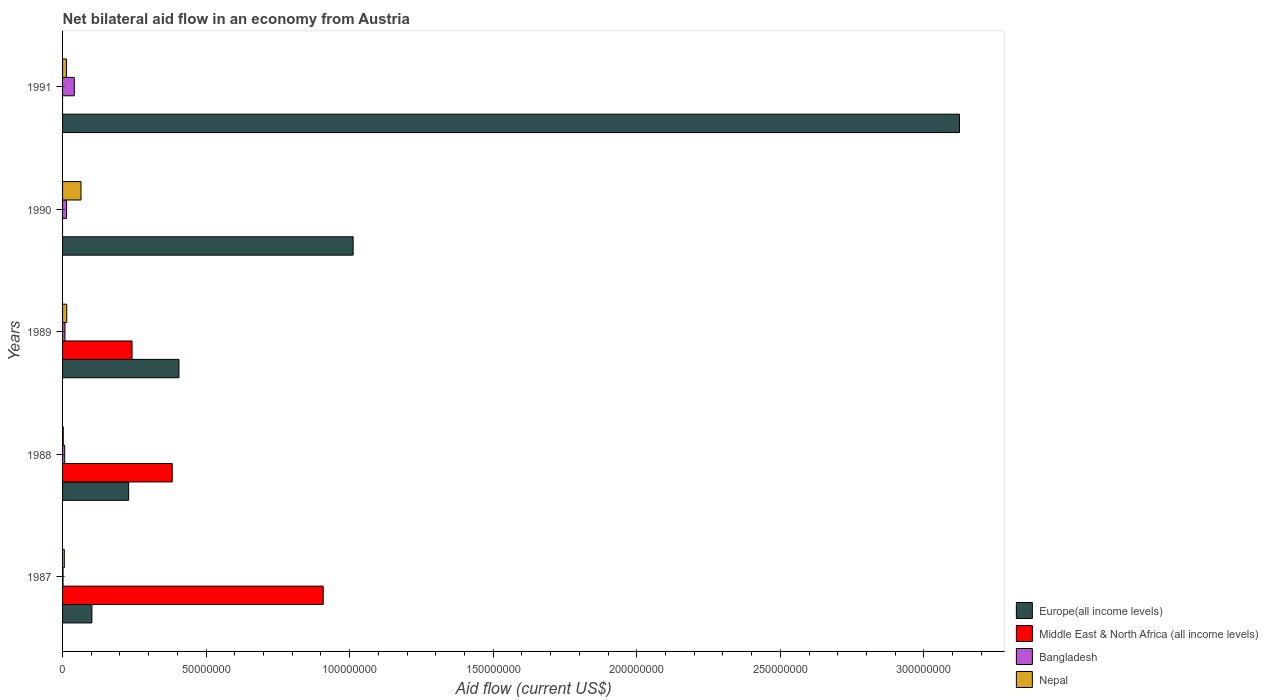Are the number of bars per tick equal to the number of legend labels?
Make the answer very short. No. What is the label of the 3rd group of bars from the top?
Your answer should be very brief. 1989. What is the net bilateral aid flow in Middle East & North Africa (all income levels) in 1989?
Ensure brevity in your answer.  2.42e+07. Across all years, what is the maximum net bilateral aid flow in Bangladesh?
Provide a succinct answer. 4.08e+06. In which year was the net bilateral aid flow in Bangladesh maximum?
Your response must be concise. 1991. What is the total net bilateral aid flow in Bangladesh in the graph?
Your answer should be very brief. 7.21e+06. What is the difference between the net bilateral aid flow in Europe(all income levels) in 1990 and the net bilateral aid flow in Nepal in 1988?
Offer a very short reply. 1.01e+08. What is the average net bilateral aid flow in Middle East & North Africa (all income levels) per year?
Offer a terse response. 3.06e+07. In the year 1987, what is the difference between the net bilateral aid flow in Middle East & North Africa (all income levels) and net bilateral aid flow in Nepal?
Provide a short and direct response. 9.02e+07. In how many years, is the net bilateral aid flow in Bangladesh greater than 20000000 US$?
Provide a short and direct response. 0. What is the ratio of the net bilateral aid flow in Nepal in 1989 to that in 1990?
Give a very brief answer. 0.23. Is the net bilateral aid flow in Nepal in 1987 less than that in 1990?
Your answer should be compact. Yes. Is the difference between the net bilateral aid flow in Middle East & North Africa (all income levels) in 1988 and 1989 greater than the difference between the net bilateral aid flow in Nepal in 1988 and 1989?
Your response must be concise. Yes. What is the difference between the highest and the second highest net bilateral aid flow in Middle East & North Africa (all income levels)?
Your answer should be very brief. 5.26e+07. What is the difference between the highest and the lowest net bilateral aid flow in Middle East & North Africa (all income levels)?
Your answer should be compact. 9.08e+07. In how many years, is the net bilateral aid flow in Europe(all income levels) greater than the average net bilateral aid flow in Europe(all income levels) taken over all years?
Ensure brevity in your answer.  2. Is the sum of the net bilateral aid flow in Europe(all income levels) in 1988 and 1990 greater than the maximum net bilateral aid flow in Middle East & North Africa (all income levels) across all years?
Your answer should be very brief. Yes. Is it the case that in every year, the sum of the net bilateral aid flow in Europe(all income levels) and net bilateral aid flow in Bangladesh is greater than the net bilateral aid flow in Nepal?
Your answer should be very brief. Yes. How many years are there in the graph?
Make the answer very short. 5. Where does the legend appear in the graph?
Ensure brevity in your answer.  Bottom right. How are the legend labels stacked?
Provide a succinct answer. Vertical. What is the title of the graph?
Provide a succinct answer. Net bilateral aid flow in an economy from Austria. What is the label or title of the Y-axis?
Provide a succinct answer. Years. What is the Aid flow (current US$) in Europe(all income levels) in 1987?
Your answer should be compact. 1.02e+07. What is the Aid flow (current US$) of Middle East & North Africa (all income levels) in 1987?
Offer a terse response. 9.08e+07. What is the Aid flow (current US$) in Bangladesh in 1987?
Your answer should be compact. 1.60e+05. What is the Aid flow (current US$) in Europe(all income levels) in 1988?
Give a very brief answer. 2.30e+07. What is the Aid flow (current US$) of Middle East & North Africa (all income levels) in 1988?
Make the answer very short. 3.82e+07. What is the Aid flow (current US$) of Bangladesh in 1988?
Offer a very short reply. 7.40e+05. What is the Aid flow (current US$) of Nepal in 1988?
Your answer should be very brief. 2.50e+05. What is the Aid flow (current US$) of Europe(all income levels) in 1989?
Your answer should be compact. 4.05e+07. What is the Aid flow (current US$) of Middle East & North Africa (all income levels) in 1989?
Make the answer very short. 2.42e+07. What is the Aid flow (current US$) of Bangladesh in 1989?
Ensure brevity in your answer.  8.40e+05. What is the Aid flow (current US$) of Nepal in 1989?
Provide a succinct answer. 1.46e+06. What is the Aid flow (current US$) of Europe(all income levels) in 1990?
Your answer should be compact. 1.01e+08. What is the Aid flow (current US$) in Middle East & North Africa (all income levels) in 1990?
Provide a short and direct response. 0. What is the Aid flow (current US$) in Bangladesh in 1990?
Your answer should be compact. 1.39e+06. What is the Aid flow (current US$) of Nepal in 1990?
Provide a short and direct response. 6.42e+06. What is the Aid flow (current US$) of Europe(all income levels) in 1991?
Your response must be concise. 3.12e+08. What is the Aid flow (current US$) in Middle East & North Africa (all income levels) in 1991?
Keep it short and to the point. 0. What is the Aid flow (current US$) of Bangladesh in 1991?
Give a very brief answer. 4.08e+06. What is the Aid flow (current US$) in Nepal in 1991?
Offer a very short reply. 1.36e+06. Across all years, what is the maximum Aid flow (current US$) in Europe(all income levels)?
Your answer should be very brief. 3.12e+08. Across all years, what is the maximum Aid flow (current US$) in Middle East & North Africa (all income levels)?
Keep it short and to the point. 9.08e+07. Across all years, what is the maximum Aid flow (current US$) in Bangladesh?
Offer a very short reply. 4.08e+06. Across all years, what is the maximum Aid flow (current US$) of Nepal?
Give a very brief answer. 6.42e+06. Across all years, what is the minimum Aid flow (current US$) of Europe(all income levels)?
Keep it short and to the point. 1.02e+07. Across all years, what is the minimum Aid flow (current US$) of Middle East & North Africa (all income levels)?
Offer a very short reply. 0. What is the total Aid flow (current US$) in Europe(all income levels) in the graph?
Offer a terse response. 4.87e+08. What is the total Aid flow (current US$) in Middle East & North Africa (all income levels) in the graph?
Offer a very short reply. 1.53e+08. What is the total Aid flow (current US$) of Bangladesh in the graph?
Your answer should be very brief. 7.21e+06. What is the total Aid flow (current US$) in Nepal in the graph?
Your answer should be compact. 1.01e+07. What is the difference between the Aid flow (current US$) in Europe(all income levels) in 1987 and that in 1988?
Your response must be concise. -1.28e+07. What is the difference between the Aid flow (current US$) of Middle East & North Africa (all income levels) in 1987 and that in 1988?
Offer a very short reply. 5.26e+07. What is the difference between the Aid flow (current US$) in Bangladesh in 1987 and that in 1988?
Your response must be concise. -5.80e+05. What is the difference between the Aid flow (current US$) in Nepal in 1987 and that in 1988?
Provide a short and direct response. 3.60e+05. What is the difference between the Aid flow (current US$) in Europe(all income levels) in 1987 and that in 1989?
Ensure brevity in your answer.  -3.03e+07. What is the difference between the Aid flow (current US$) of Middle East & North Africa (all income levels) in 1987 and that in 1989?
Provide a succinct answer. 6.66e+07. What is the difference between the Aid flow (current US$) of Bangladesh in 1987 and that in 1989?
Offer a very short reply. -6.80e+05. What is the difference between the Aid flow (current US$) in Nepal in 1987 and that in 1989?
Ensure brevity in your answer.  -8.50e+05. What is the difference between the Aid flow (current US$) in Europe(all income levels) in 1987 and that in 1990?
Offer a terse response. -9.10e+07. What is the difference between the Aid flow (current US$) of Bangladesh in 1987 and that in 1990?
Offer a terse response. -1.23e+06. What is the difference between the Aid flow (current US$) of Nepal in 1987 and that in 1990?
Ensure brevity in your answer.  -5.81e+06. What is the difference between the Aid flow (current US$) of Europe(all income levels) in 1987 and that in 1991?
Your answer should be very brief. -3.02e+08. What is the difference between the Aid flow (current US$) in Bangladesh in 1987 and that in 1991?
Your answer should be very brief. -3.92e+06. What is the difference between the Aid flow (current US$) in Nepal in 1987 and that in 1991?
Your answer should be compact. -7.50e+05. What is the difference between the Aid flow (current US$) of Europe(all income levels) in 1988 and that in 1989?
Give a very brief answer. -1.75e+07. What is the difference between the Aid flow (current US$) of Middle East & North Africa (all income levels) in 1988 and that in 1989?
Ensure brevity in your answer.  1.40e+07. What is the difference between the Aid flow (current US$) of Bangladesh in 1988 and that in 1989?
Keep it short and to the point. -1.00e+05. What is the difference between the Aid flow (current US$) in Nepal in 1988 and that in 1989?
Ensure brevity in your answer.  -1.21e+06. What is the difference between the Aid flow (current US$) in Europe(all income levels) in 1988 and that in 1990?
Your response must be concise. -7.82e+07. What is the difference between the Aid flow (current US$) of Bangladesh in 1988 and that in 1990?
Your answer should be compact. -6.50e+05. What is the difference between the Aid flow (current US$) in Nepal in 1988 and that in 1990?
Keep it short and to the point. -6.17e+06. What is the difference between the Aid flow (current US$) in Europe(all income levels) in 1988 and that in 1991?
Provide a short and direct response. -2.89e+08. What is the difference between the Aid flow (current US$) in Bangladesh in 1988 and that in 1991?
Offer a terse response. -3.34e+06. What is the difference between the Aid flow (current US$) of Nepal in 1988 and that in 1991?
Offer a very short reply. -1.11e+06. What is the difference between the Aid flow (current US$) in Europe(all income levels) in 1989 and that in 1990?
Provide a short and direct response. -6.07e+07. What is the difference between the Aid flow (current US$) in Bangladesh in 1989 and that in 1990?
Your answer should be compact. -5.50e+05. What is the difference between the Aid flow (current US$) in Nepal in 1989 and that in 1990?
Your answer should be very brief. -4.96e+06. What is the difference between the Aid flow (current US$) of Europe(all income levels) in 1989 and that in 1991?
Provide a short and direct response. -2.72e+08. What is the difference between the Aid flow (current US$) in Bangladesh in 1989 and that in 1991?
Offer a terse response. -3.24e+06. What is the difference between the Aid flow (current US$) of Nepal in 1989 and that in 1991?
Provide a succinct answer. 1.00e+05. What is the difference between the Aid flow (current US$) in Europe(all income levels) in 1990 and that in 1991?
Give a very brief answer. -2.11e+08. What is the difference between the Aid flow (current US$) in Bangladesh in 1990 and that in 1991?
Make the answer very short. -2.69e+06. What is the difference between the Aid flow (current US$) of Nepal in 1990 and that in 1991?
Offer a terse response. 5.06e+06. What is the difference between the Aid flow (current US$) of Europe(all income levels) in 1987 and the Aid flow (current US$) of Middle East & North Africa (all income levels) in 1988?
Ensure brevity in your answer.  -2.80e+07. What is the difference between the Aid flow (current US$) in Europe(all income levels) in 1987 and the Aid flow (current US$) in Bangladesh in 1988?
Offer a very short reply. 9.48e+06. What is the difference between the Aid flow (current US$) of Europe(all income levels) in 1987 and the Aid flow (current US$) of Nepal in 1988?
Offer a very short reply. 9.97e+06. What is the difference between the Aid flow (current US$) of Middle East & North Africa (all income levels) in 1987 and the Aid flow (current US$) of Bangladesh in 1988?
Your answer should be compact. 9.00e+07. What is the difference between the Aid flow (current US$) in Middle East & North Africa (all income levels) in 1987 and the Aid flow (current US$) in Nepal in 1988?
Your answer should be compact. 9.05e+07. What is the difference between the Aid flow (current US$) in Bangladesh in 1987 and the Aid flow (current US$) in Nepal in 1988?
Your answer should be compact. -9.00e+04. What is the difference between the Aid flow (current US$) of Europe(all income levels) in 1987 and the Aid flow (current US$) of Middle East & North Africa (all income levels) in 1989?
Keep it short and to the point. -1.40e+07. What is the difference between the Aid flow (current US$) in Europe(all income levels) in 1987 and the Aid flow (current US$) in Bangladesh in 1989?
Provide a short and direct response. 9.38e+06. What is the difference between the Aid flow (current US$) of Europe(all income levels) in 1987 and the Aid flow (current US$) of Nepal in 1989?
Ensure brevity in your answer.  8.76e+06. What is the difference between the Aid flow (current US$) in Middle East & North Africa (all income levels) in 1987 and the Aid flow (current US$) in Bangladesh in 1989?
Give a very brief answer. 9.00e+07. What is the difference between the Aid flow (current US$) of Middle East & North Africa (all income levels) in 1987 and the Aid flow (current US$) of Nepal in 1989?
Provide a succinct answer. 8.93e+07. What is the difference between the Aid flow (current US$) in Bangladesh in 1987 and the Aid flow (current US$) in Nepal in 1989?
Offer a terse response. -1.30e+06. What is the difference between the Aid flow (current US$) in Europe(all income levels) in 1987 and the Aid flow (current US$) in Bangladesh in 1990?
Provide a succinct answer. 8.83e+06. What is the difference between the Aid flow (current US$) of Europe(all income levels) in 1987 and the Aid flow (current US$) of Nepal in 1990?
Your response must be concise. 3.80e+06. What is the difference between the Aid flow (current US$) in Middle East & North Africa (all income levels) in 1987 and the Aid flow (current US$) in Bangladesh in 1990?
Provide a short and direct response. 8.94e+07. What is the difference between the Aid flow (current US$) in Middle East & North Africa (all income levels) in 1987 and the Aid flow (current US$) in Nepal in 1990?
Offer a very short reply. 8.44e+07. What is the difference between the Aid flow (current US$) of Bangladesh in 1987 and the Aid flow (current US$) of Nepal in 1990?
Your response must be concise. -6.26e+06. What is the difference between the Aid flow (current US$) of Europe(all income levels) in 1987 and the Aid flow (current US$) of Bangladesh in 1991?
Make the answer very short. 6.14e+06. What is the difference between the Aid flow (current US$) in Europe(all income levels) in 1987 and the Aid flow (current US$) in Nepal in 1991?
Your response must be concise. 8.86e+06. What is the difference between the Aid flow (current US$) in Middle East & North Africa (all income levels) in 1987 and the Aid flow (current US$) in Bangladesh in 1991?
Keep it short and to the point. 8.67e+07. What is the difference between the Aid flow (current US$) of Middle East & North Africa (all income levels) in 1987 and the Aid flow (current US$) of Nepal in 1991?
Your response must be concise. 8.94e+07. What is the difference between the Aid flow (current US$) of Bangladesh in 1987 and the Aid flow (current US$) of Nepal in 1991?
Keep it short and to the point. -1.20e+06. What is the difference between the Aid flow (current US$) of Europe(all income levels) in 1988 and the Aid flow (current US$) of Middle East & North Africa (all income levels) in 1989?
Your answer should be very brief. -1.19e+06. What is the difference between the Aid flow (current US$) of Europe(all income levels) in 1988 and the Aid flow (current US$) of Bangladesh in 1989?
Your response must be concise. 2.22e+07. What is the difference between the Aid flow (current US$) of Europe(all income levels) in 1988 and the Aid flow (current US$) of Nepal in 1989?
Make the answer very short. 2.16e+07. What is the difference between the Aid flow (current US$) of Middle East & North Africa (all income levels) in 1988 and the Aid flow (current US$) of Bangladesh in 1989?
Provide a succinct answer. 3.74e+07. What is the difference between the Aid flow (current US$) in Middle East & North Africa (all income levels) in 1988 and the Aid flow (current US$) in Nepal in 1989?
Your answer should be compact. 3.67e+07. What is the difference between the Aid flow (current US$) in Bangladesh in 1988 and the Aid flow (current US$) in Nepal in 1989?
Keep it short and to the point. -7.20e+05. What is the difference between the Aid flow (current US$) in Europe(all income levels) in 1988 and the Aid flow (current US$) in Bangladesh in 1990?
Provide a succinct answer. 2.16e+07. What is the difference between the Aid flow (current US$) of Europe(all income levels) in 1988 and the Aid flow (current US$) of Nepal in 1990?
Your answer should be compact. 1.66e+07. What is the difference between the Aid flow (current US$) in Middle East & North Africa (all income levels) in 1988 and the Aid flow (current US$) in Bangladesh in 1990?
Make the answer very short. 3.68e+07. What is the difference between the Aid flow (current US$) in Middle East & North Africa (all income levels) in 1988 and the Aid flow (current US$) in Nepal in 1990?
Your response must be concise. 3.18e+07. What is the difference between the Aid flow (current US$) of Bangladesh in 1988 and the Aid flow (current US$) of Nepal in 1990?
Make the answer very short. -5.68e+06. What is the difference between the Aid flow (current US$) in Europe(all income levels) in 1988 and the Aid flow (current US$) in Bangladesh in 1991?
Provide a succinct answer. 1.89e+07. What is the difference between the Aid flow (current US$) in Europe(all income levels) in 1988 and the Aid flow (current US$) in Nepal in 1991?
Your answer should be very brief. 2.16e+07. What is the difference between the Aid flow (current US$) of Middle East & North Africa (all income levels) in 1988 and the Aid flow (current US$) of Bangladesh in 1991?
Offer a very short reply. 3.41e+07. What is the difference between the Aid flow (current US$) in Middle East & North Africa (all income levels) in 1988 and the Aid flow (current US$) in Nepal in 1991?
Keep it short and to the point. 3.68e+07. What is the difference between the Aid flow (current US$) of Bangladesh in 1988 and the Aid flow (current US$) of Nepal in 1991?
Provide a short and direct response. -6.20e+05. What is the difference between the Aid flow (current US$) of Europe(all income levels) in 1989 and the Aid flow (current US$) of Bangladesh in 1990?
Ensure brevity in your answer.  3.92e+07. What is the difference between the Aid flow (current US$) in Europe(all income levels) in 1989 and the Aid flow (current US$) in Nepal in 1990?
Your response must be concise. 3.41e+07. What is the difference between the Aid flow (current US$) in Middle East & North Africa (all income levels) in 1989 and the Aid flow (current US$) in Bangladesh in 1990?
Make the answer very short. 2.28e+07. What is the difference between the Aid flow (current US$) in Middle East & North Africa (all income levels) in 1989 and the Aid flow (current US$) in Nepal in 1990?
Your answer should be compact. 1.78e+07. What is the difference between the Aid flow (current US$) in Bangladesh in 1989 and the Aid flow (current US$) in Nepal in 1990?
Your answer should be very brief. -5.58e+06. What is the difference between the Aid flow (current US$) of Europe(all income levels) in 1989 and the Aid flow (current US$) of Bangladesh in 1991?
Provide a short and direct response. 3.65e+07. What is the difference between the Aid flow (current US$) in Europe(all income levels) in 1989 and the Aid flow (current US$) in Nepal in 1991?
Your response must be concise. 3.92e+07. What is the difference between the Aid flow (current US$) of Middle East & North Africa (all income levels) in 1989 and the Aid flow (current US$) of Bangladesh in 1991?
Your answer should be very brief. 2.01e+07. What is the difference between the Aid flow (current US$) in Middle East & North Africa (all income levels) in 1989 and the Aid flow (current US$) in Nepal in 1991?
Provide a succinct answer. 2.28e+07. What is the difference between the Aid flow (current US$) in Bangladesh in 1989 and the Aid flow (current US$) in Nepal in 1991?
Your answer should be compact. -5.20e+05. What is the difference between the Aid flow (current US$) of Europe(all income levels) in 1990 and the Aid flow (current US$) of Bangladesh in 1991?
Give a very brief answer. 9.71e+07. What is the difference between the Aid flow (current US$) in Europe(all income levels) in 1990 and the Aid flow (current US$) in Nepal in 1991?
Make the answer very short. 9.98e+07. What is the difference between the Aid flow (current US$) of Bangladesh in 1990 and the Aid flow (current US$) of Nepal in 1991?
Make the answer very short. 3.00e+04. What is the average Aid flow (current US$) of Europe(all income levels) per year?
Offer a very short reply. 9.75e+07. What is the average Aid flow (current US$) in Middle East & North Africa (all income levels) per year?
Give a very brief answer. 3.06e+07. What is the average Aid flow (current US$) of Bangladesh per year?
Your answer should be very brief. 1.44e+06. What is the average Aid flow (current US$) in Nepal per year?
Your answer should be very brief. 2.02e+06. In the year 1987, what is the difference between the Aid flow (current US$) of Europe(all income levels) and Aid flow (current US$) of Middle East & North Africa (all income levels)?
Your answer should be very brief. -8.06e+07. In the year 1987, what is the difference between the Aid flow (current US$) of Europe(all income levels) and Aid flow (current US$) of Bangladesh?
Keep it short and to the point. 1.01e+07. In the year 1987, what is the difference between the Aid flow (current US$) of Europe(all income levels) and Aid flow (current US$) of Nepal?
Provide a succinct answer. 9.61e+06. In the year 1987, what is the difference between the Aid flow (current US$) of Middle East & North Africa (all income levels) and Aid flow (current US$) of Bangladesh?
Make the answer very short. 9.06e+07. In the year 1987, what is the difference between the Aid flow (current US$) in Middle East & North Africa (all income levels) and Aid flow (current US$) in Nepal?
Offer a very short reply. 9.02e+07. In the year 1987, what is the difference between the Aid flow (current US$) in Bangladesh and Aid flow (current US$) in Nepal?
Offer a terse response. -4.50e+05. In the year 1988, what is the difference between the Aid flow (current US$) in Europe(all income levels) and Aid flow (current US$) in Middle East & North Africa (all income levels)?
Give a very brief answer. -1.52e+07. In the year 1988, what is the difference between the Aid flow (current US$) in Europe(all income levels) and Aid flow (current US$) in Bangladesh?
Your response must be concise. 2.23e+07. In the year 1988, what is the difference between the Aid flow (current US$) of Europe(all income levels) and Aid flow (current US$) of Nepal?
Provide a succinct answer. 2.28e+07. In the year 1988, what is the difference between the Aid flow (current US$) in Middle East & North Africa (all income levels) and Aid flow (current US$) in Bangladesh?
Your answer should be very brief. 3.74e+07. In the year 1988, what is the difference between the Aid flow (current US$) in Middle East & North Africa (all income levels) and Aid flow (current US$) in Nepal?
Offer a terse response. 3.79e+07. In the year 1989, what is the difference between the Aid flow (current US$) in Europe(all income levels) and Aid flow (current US$) in Middle East & North Africa (all income levels)?
Your answer should be compact. 1.63e+07. In the year 1989, what is the difference between the Aid flow (current US$) in Europe(all income levels) and Aid flow (current US$) in Bangladesh?
Your answer should be compact. 3.97e+07. In the year 1989, what is the difference between the Aid flow (current US$) of Europe(all income levels) and Aid flow (current US$) of Nepal?
Ensure brevity in your answer.  3.91e+07. In the year 1989, what is the difference between the Aid flow (current US$) in Middle East & North Africa (all income levels) and Aid flow (current US$) in Bangladesh?
Keep it short and to the point. 2.34e+07. In the year 1989, what is the difference between the Aid flow (current US$) of Middle East & North Africa (all income levels) and Aid flow (current US$) of Nepal?
Your answer should be compact. 2.27e+07. In the year 1989, what is the difference between the Aid flow (current US$) in Bangladesh and Aid flow (current US$) in Nepal?
Your answer should be very brief. -6.20e+05. In the year 1990, what is the difference between the Aid flow (current US$) of Europe(all income levels) and Aid flow (current US$) of Bangladesh?
Your answer should be very brief. 9.98e+07. In the year 1990, what is the difference between the Aid flow (current US$) in Europe(all income levels) and Aid flow (current US$) in Nepal?
Your response must be concise. 9.48e+07. In the year 1990, what is the difference between the Aid flow (current US$) of Bangladesh and Aid flow (current US$) of Nepal?
Your response must be concise. -5.03e+06. In the year 1991, what is the difference between the Aid flow (current US$) in Europe(all income levels) and Aid flow (current US$) in Bangladesh?
Your answer should be compact. 3.08e+08. In the year 1991, what is the difference between the Aid flow (current US$) in Europe(all income levels) and Aid flow (current US$) in Nepal?
Provide a short and direct response. 3.11e+08. In the year 1991, what is the difference between the Aid flow (current US$) of Bangladesh and Aid flow (current US$) of Nepal?
Your answer should be compact. 2.72e+06. What is the ratio of the Aid flow (current US$) of Europe(all income levels) in 1987 to that in 1988?
Offer a very short reply. 0.44. What is the ratio of the Aid flow (current US$) in Middle East & North Africa (all income levels) in 1987 to that in 1988?
Make the answer very short. 2.38. What is the ratio of the Aid flow (current US$) of Bangladesh in 1987 to that in 1988?
Make the answer very short. 0.22. What is the ratio of the Aid flow (current US$) of Nepal in 1987 to that in 1988?
Give a very brief answer. 2.44. What is the ratio of the Aid flow (current US$) in Europe(all income levels) in 1987 to that in 1989?
Offer a terse response. 0.25. What is the ratio of the Aid flow (current US$) of Middle East & North Africa (all income levels) in 1987 to that in 1989?
Ensure brevity in your answer.  3.75. What is the ratio of the Aid flow (current US$) in Bangladesh in 1987 to that in 1989?
Offer a terse response. 0.19. What is the ratio of the Aid flow (current US$) of Nepal in 1987 to that in 1989?
Offer a terse response. 0.42. What is the ratio of the Aid flow (current US$) in Europe(all income levels) in 1987 to that in 1990?
Your answer should be compact. 0.1. What is the ratio of the Aid flow (current US$) in Bangladesh in 1987 to that in 1990?
Your answer should be very brief. 0.12. What is the ratio of the Aid flow (current US$) of Nepal in 1987 to that in 1990?
Give a very brief answer. 0.1. What is the ratio of the Aid flow (current US$) in Europe(all income levels) in 1987 to that in 1991?
Your answer should be very brief. 0.03. What is the ratio of the Aid flow (current US$) of Bangladesh in 1987 to that in 1991?
Keep it short and to the point. 0.04. What is the ratio of the Aid flow (current US$) of Nepal in 1987 to that in 1991?
Give a very brief answer. 0.45. What is the ratio of the Aid flow (current US$) in Europe(all income levels) in 1988 to that in 1989?
Your response must be concise. 0.57. What is the ratio of the Aid flow (current US$) in Middle East & North Africa (all income levels) in 1988 to that in 1989?
Offer a terse response. 1.58. What is the ratio of the Aid flow (current US$) of Bangladesh in 1988 to that in 1989?
Ensure brevity in your answer.  0.88. What is the ratio of the Aid flow (current US$) of Nepal in 1988 to that in 1989?
Keep it short and to the point. 0.17. What is the ratio of the Aid flow (current US$) in Europe(all income levels) in 1988 to that in 1990?
Provide a short and direct response. 0.23. What is the ratio of the Aid flow (current US$) of Bangladesh in 1988 to that in 1990?
Your response must be concise. 0.53. What is the ratio of the Aid flow (current US$) in Nepal in 1988 to that in 1990?
Your answer should be very brief. 0.04. What is the ratio of the Aid flow (current US$) of Europe(all income levels) in 1988 to that in 1991?
Ensure brevity in your answer.  0.07. What is the ratio of the Aid flow (current US$) in Bangladesh in 1988 to that in 1991?
Ensure brevity in your answer.  0.18. What is the ratio of the Aid flow (current US$) of Nepal in 1988 to that in 1991?
Ensure brevity in your answer.  0.18. What is the ratio of the Aid flow (current US$) in Europe(all income levels) in 1989 to that in 1990?
Your answer should be very brief. 0.4. What is the ratio of the Aid flow (current US$) in Bangladesh in 1989 to that in 1990?
Make the answer very short. 0.6. What is the ratio of the Aid flow (current US$) of Nepal in 1989 to that in 1990?
Ensure brevity in your answer.  0.23. What is the ratio of the Aid flow (current US$) in Europe(all income levels) in 1989 to that in 1991?
Offer a very short reply. 0.13. What is the ratio of the Aid flow (current US$) of Bangladesh in 1989 to that in 1991?
Offer a terse response. 0.21. What is the ratio of the Aid flow (current US$) of Nepal in 1989 to that in 1991?
Ensure brevity in your answer.  1.07. What is the ratio of the Aid flow (current US$) in Europe(all income levels) in 1990 to that in 1991?
Provide a succinct answer. 0.32. What is the ratio of the Aid flow (current US$) of Bangladesh in 1990 to that in 1991?
Your answer should be compact. 0.34. What is the ratio of the Aid flow (current US$) of Nepal in 1990 to that in 1991?
Give a very brief answer. 4.72. What is the difference between the highest and the second highest Aid flow (current US$) in Europe(all income levels)?
Provide a succinct answer. 2.11e+08. What is the difference between the highest and the second highest Aid flow (current US$) of Middle East & North Africa (all income levels)?
Provide a short and direct response. 5.26e+07. What is the difference between the highest and the second highest Aid flow (current US$) of Bangladesh?
Offer a very short reply. 2.69e+06. What is the difference between the highest and the second highest Aid flow (current US$) of Nepal?
Give a very brief answer. 4.96e+06. What is the difference between the highest and the lowest Aid flow (current US$) in Europe(all income levels)?
Give a very brief answer. 3.02e+08. What is the difference between the highest and the lowest Aid flow (current US$) in Middle East & North Africa (all income levels)?
Your response must be concise. 9.08e+07. What is the difference between the highest and the lowest Aid flow (current US$) in Bangladesh?
Keep it short and to the point. 3.92e+06. What is the difference between the highest and the lowest Aid flow (current US$) in Nepal?
Offer a terse response. 6.17e+06. 